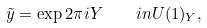<formula> <loc_0><loc_0><loc_500><loc_500>\tilde { y } = \exp 2 \pi i Y \quad i n U ( 1 ) _ { Y } ,</formula> 